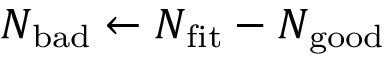<formula> <loc_0><loc_0><loc_500><loc_500>N _ { b a d } \leftarrow N _ { f i t } - N _ { g o o d }</formula> 